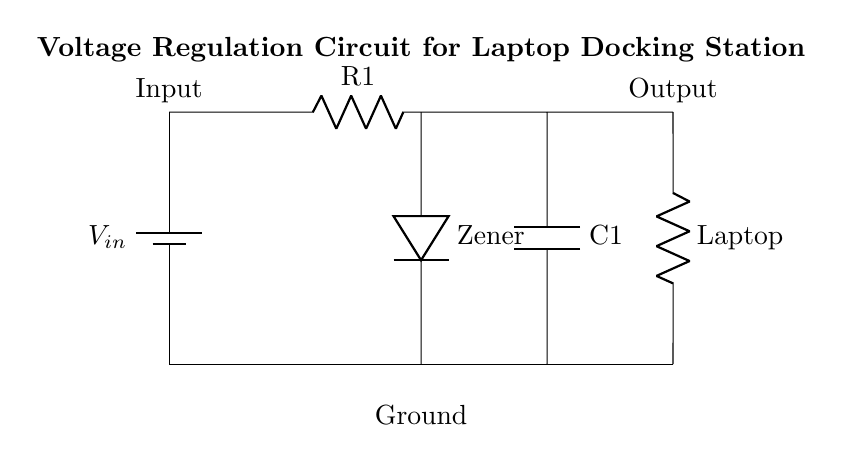What is the input voltage labeled as? The input voltage in the circuit is labeled as V_in, which can be found next to the battery component at the top left of the diagram.
Answer: V_in What type of component is used for voltage regulation? The circuit uses a Zener diode for voltage regulation, indicated by the label "Zener" next to the corresponding component in the diagram.
Answer: Zener diode What is the load connected in this circuit? The load in this circuit is a resistor labeled as "Laptop," indicating that it represents the laptop connected to the docking station.
Answer: Laptop What is the function of capacitor C1? Capacitor C1 is connected in parallel to the output and is commonly used for filtering, helping to smooth out any voltage fluctuations, but the diagram directly shows it next to the output.
Answer: Filtering How does the Zener diode affect the voltage output? The Zener diode allows current to flow in the reverse direction when the voltage exceeds a certain level, thus regulating and maintaining a stable output voltage across the load, as illustrated by its placement in the circuit diagram.
Answer: Regulates voltage What is the total resistance in this circuit? The circuit has a single resistor labeled R1 in series before the Zener diode, and while other resistances may exist in practical scenarios, the diagram points to R1 as the identified resistance.
Answer: R1 